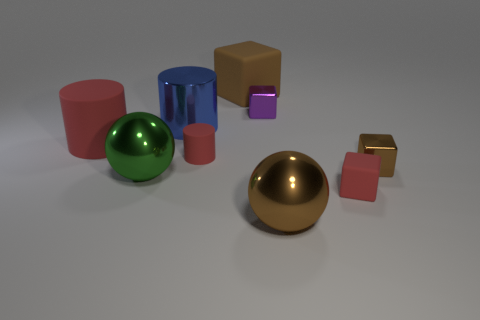Subtract all cylinders. How many objects are left? 6 Subtract all green metal things. Subtract all brown things. How many objects are left? 5 Add 8 tiny red cylinders. How many tiny red cylinders are left? 9 Add 9 large gray things. How many large gray things exist? 9 Subtract 1 brown spheres. How many objects are left? 8 